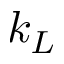Convert formula to latex. <formula><loc_0><loc_0><loc_500><loc_500>k _ { L }</formula> 